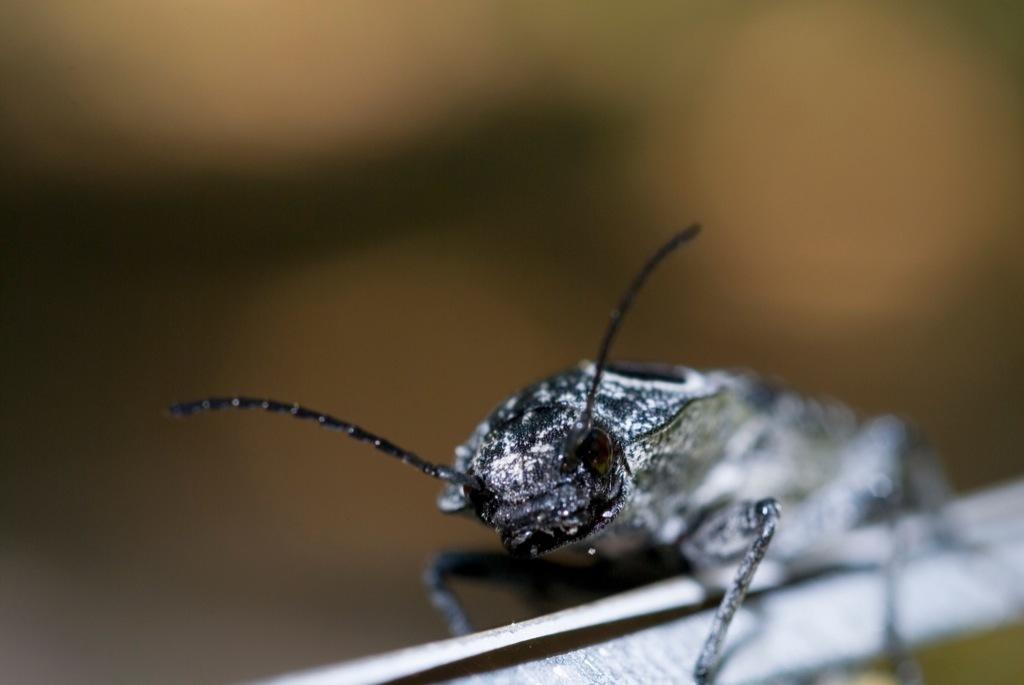What type of creature can be seen in the image? There is an insect in the image. Can you describe the background of the image? The background of the image is blurry. What color is the impulse that the insect is emitting in the image? There is no impulse being emitted by the insect in the image, and therefore no color can be determined. 